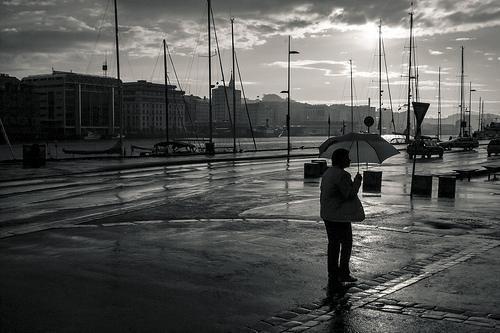How many people are in the picture?
Give a very brief answer. 1. 